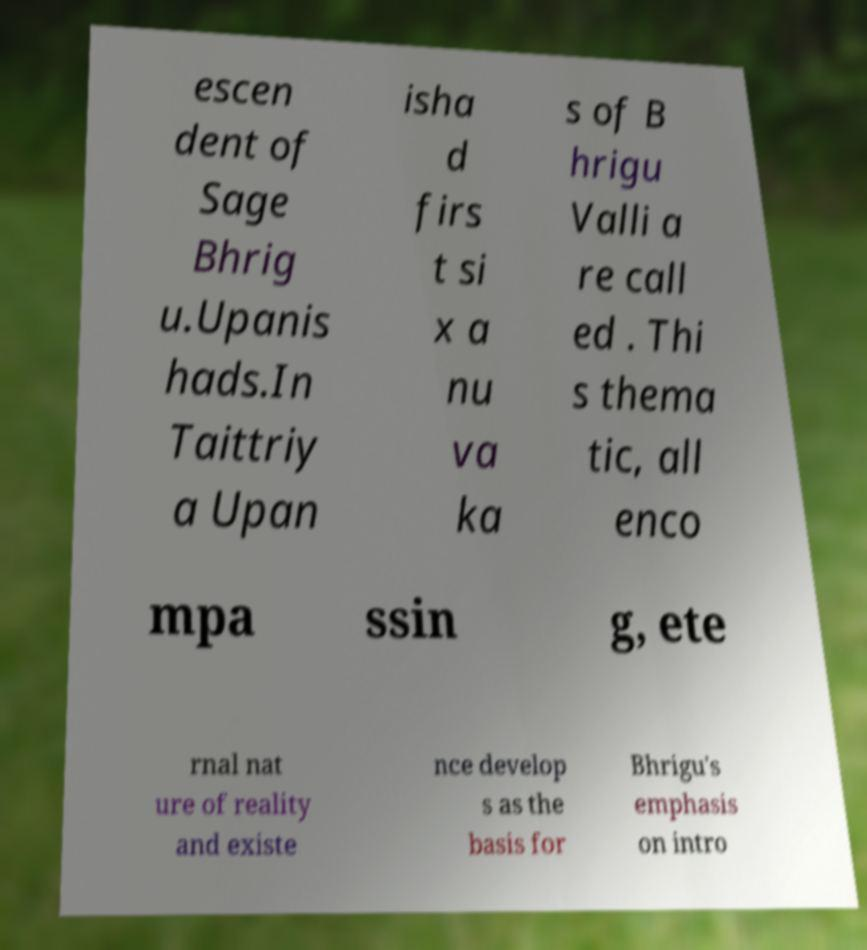Can you accurately transcribe the text from the provided image for me? escen dent of Sage Bhrig u.Upanis hads.In Taittriy a Upan isha d firs t si x a nu va ka s of B hrigu Valli a re call ed . Thi s thema tic, all enco mpa ssin g, ete rnal nat ure of reality and existe nce develop s as the basis for Bhrigu's emphasis on intro 